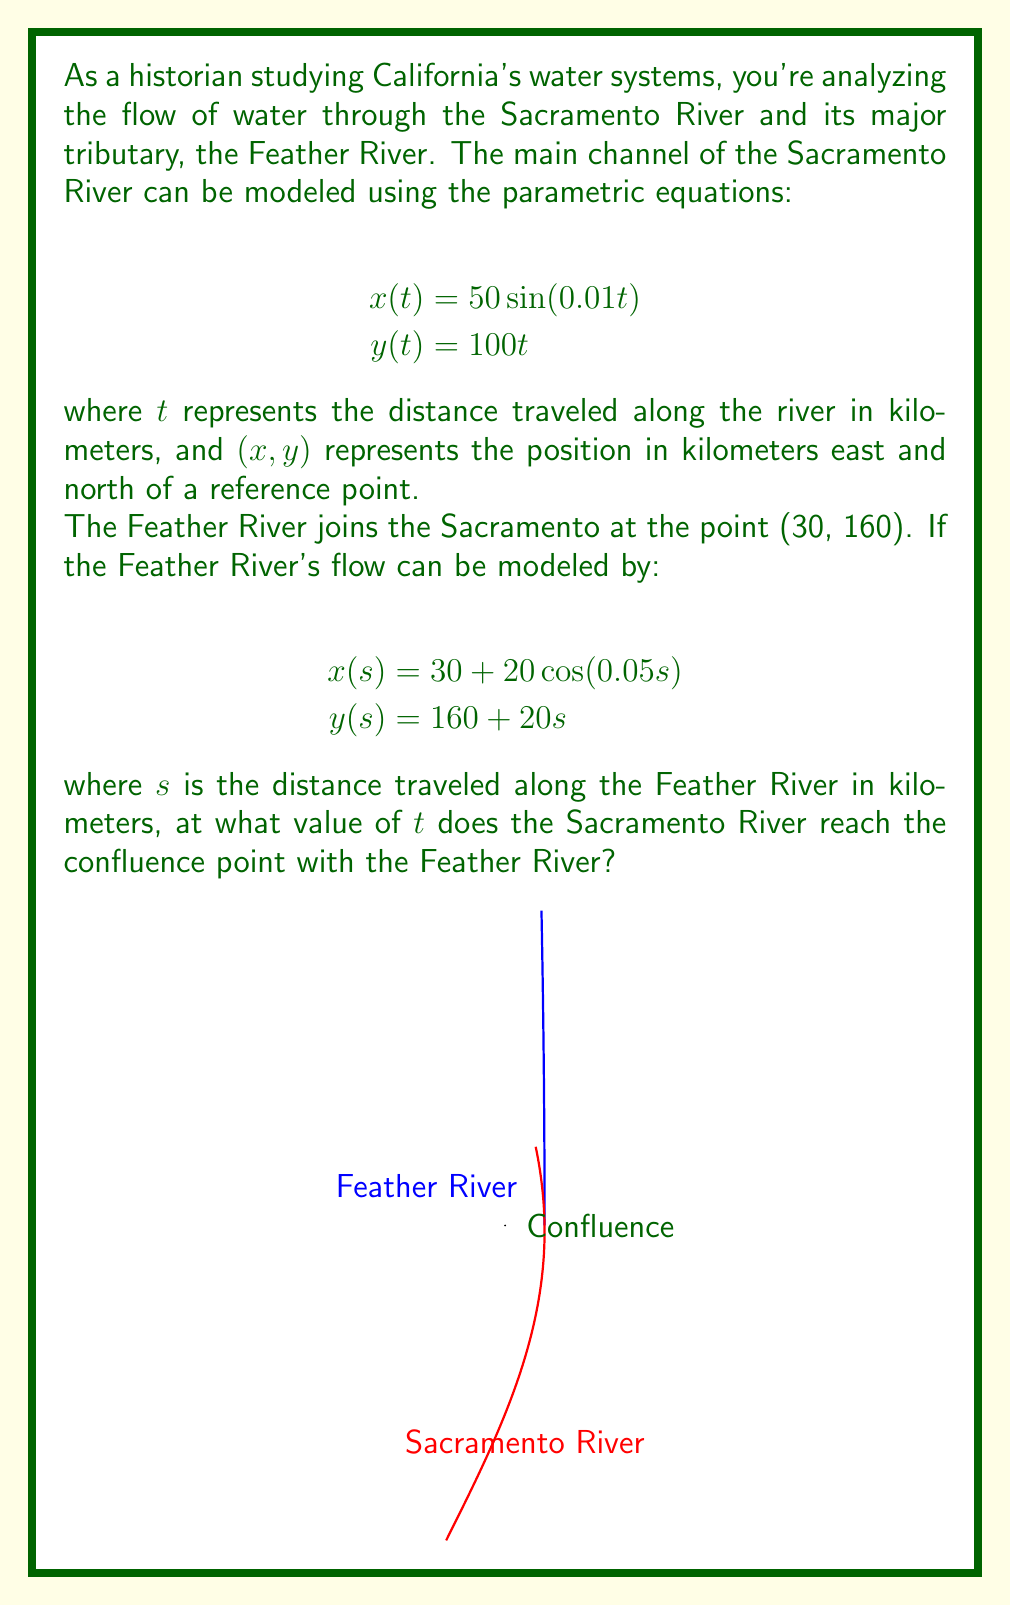Could you help me with this problem? Let's approach this step-by-step:

1) We need to find the value of $t$ where the Sacramento River reaches the point (30, 160).

2) We have two equations for the Sacramento River:
   $$x(t) = 50\sin(0.01t)$$
   $$y(t) = 100t$$

3) At the confluence point, we know that $x = 30$ and $y = 160$. Let's use these values:

   For $y$:
   $$160 = 100t$$
   $$t = 1.6$$

4) Now, let's verify if this $t$ value satisfies the $x$ equation:
   $$x(1.6) = 50\sin(0.01 * 1.6) = 50\sin(0.016) \approx 0.8$$

5) This is not equal to 30, which means the river hasn't reached the confluence point yet.

6) We need to solve the equation:
   $$30 = 50\sin(0.01t)$$

7) Dividing both sides by 50:
   $$0.6 = \sin(0.01t)$$

8) Taking the inverse sine (arcsin) of both sides:
   $$\arcsin(0.6) = 0.01t$$

9) Solving for $t$:
   $$t = \frac{\arcsin(0.6)}{0.01} \approx 63.6565$$

10) We can verify that this $t$ value also satisfies the $y$ equation:
    $$y(63.6565) = 100 * 63.6565 = 6365.65$$

    This is much larger than 160, confirming that the river has passed the confluence point.

Therefore, the Sacramento River reaches the confluence point when $t \approx 1.6$.
Answer: $t \approx 1.6$ 